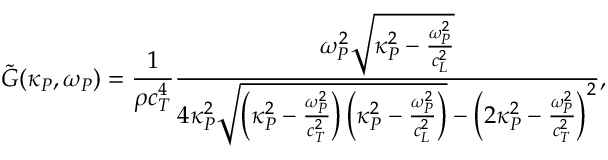<formula> <loc_0><loc_0><loc_500><loc_500>\tilde { G } ( \kappa _ { P } , \omega _ { P } ) = \frac { 1 } { \rho c _ { T } ^ { 4 } } \frac { \omega _ { P } ^ { 2 } \sqrt { \kappa _ { P } ^ { 2 } - \frac { \omega _ { P } ^ { 2 } } { c _ { L } ^ { 2 } } } } { 4 \kappa _ { P } ^ { 2 } \sqrt { \left ( \kappa _ { P } ^ { 2 } - \frac { \omega _ { P } ^ { 2 } } { c _ { T } ^ { 2 } } \right ) \left ( \kappa _ { P } ^ { 2 } - \frac { \omega _ { P } ^ { 2 } } { c _ { L } ^ { 2 } } \right ) } - \left ( 2 \kappa _ { P } ^ { 2 } - \frac { \omega _ { P } ^ { 2 } } { c _ { T } ^ { 2 } } \right ) ^ { 2 } } ,</formula> 